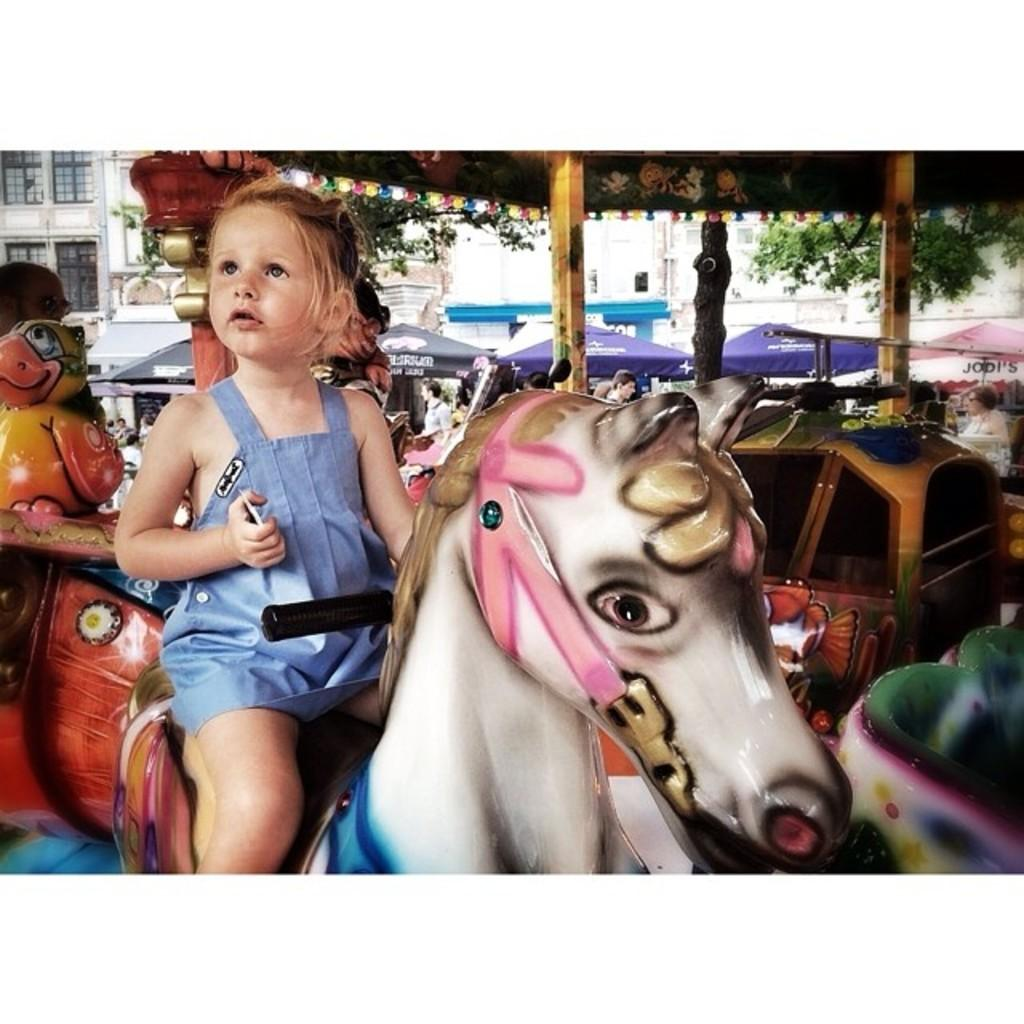Who is the main subject in the image? There is a baby girl in the image. What is the baby girl doing in the image? The baby girl is sitting on a toy horse. What can be seen in the background of the image? There is a tree, a building, and a tent in the background of the image. What type of stove can be seen in the image? There is no stove present in the image. What is the baby girl's voice like in the image? The image is a still photograph, so there is no sound or voice present. 